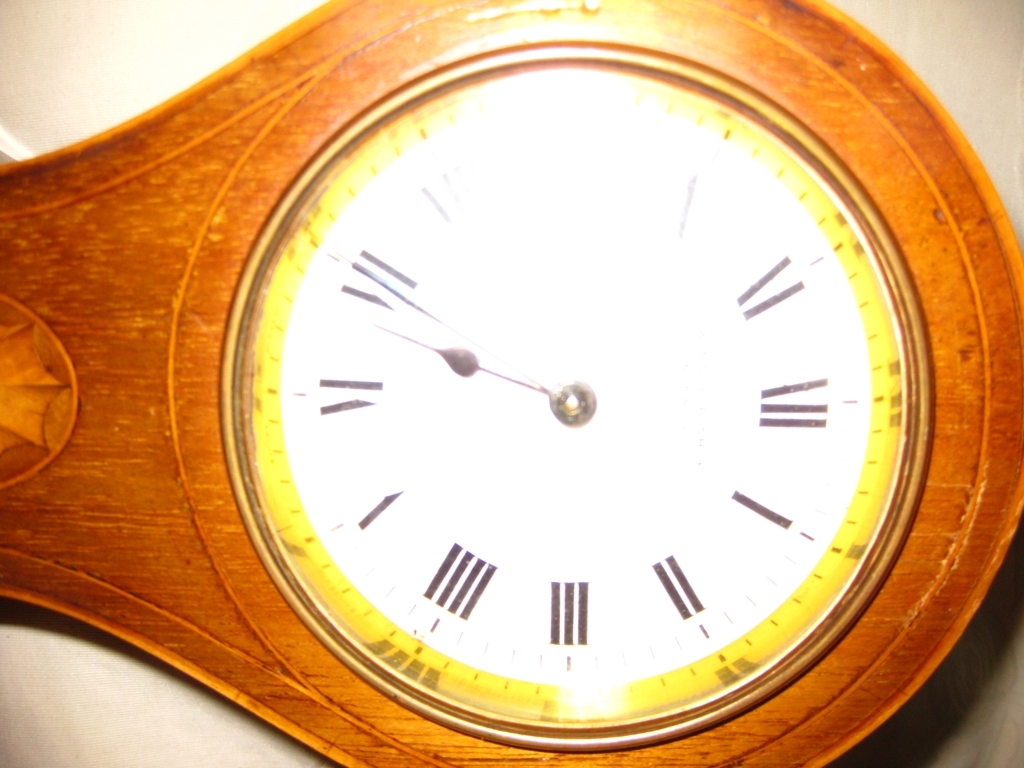What is the problem with the center part of this image?
A. Perfectly exposed
B. Slightly overexposed
C. Underexposed The center portion of the image, which features the clock face, is B. Slightly overexposed. This can be observed as the light reflects more intensely off the center, causing the details to lose some of their clarity and making the white of the clock face appear very bright in contrast to the rest of the image. 